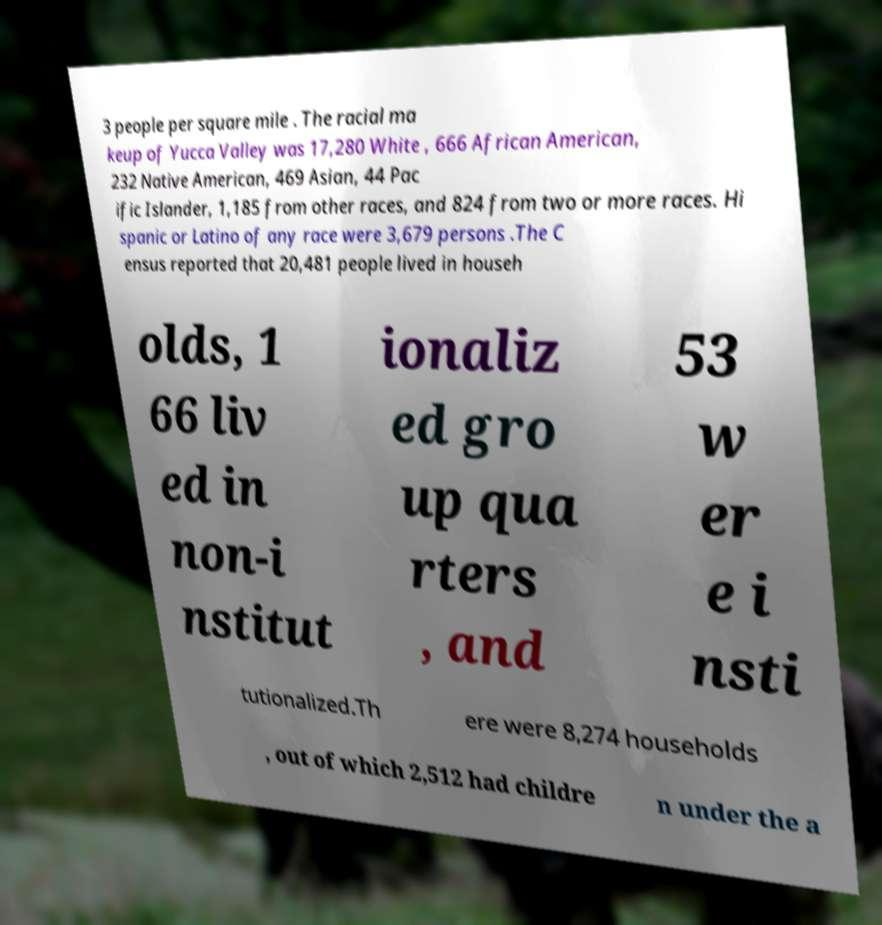There's text embedded in this image that I need extracted. Can you transcribe it verbatim? 3 people per square mile . The racial ma keup of Yucca Valley was 17,280 White , 666 African American, 232 Native American, 469 Asian, 44 Pac ific Islander, 1,185 from other races, and 824 from two or more races. Hi spanic or Latino of any race were 3,679 persons .The C ensus reported that 20,481 people lived in househ olds, 1 66 liv ed in non-i nstitut ionaliz ed gro up qua rters , and 53 w er e i nsti tutionalized.Th ere were 8,274 households , out of which 2,512 had childre n under the a 